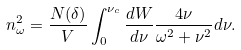<formula> <loc_0><loc_0><loc_500><loc_500>n ^ { 2 } _ { \omega } = \frac { N ( \delta ) } { V } \int _ { 0 } ^ { \nu _ { c } } \frac { d W } { d \nu } \frac { 4 \nu } { \omega ^ { 2 } + \nu ^ { 2 } } d \nu .</formula> 